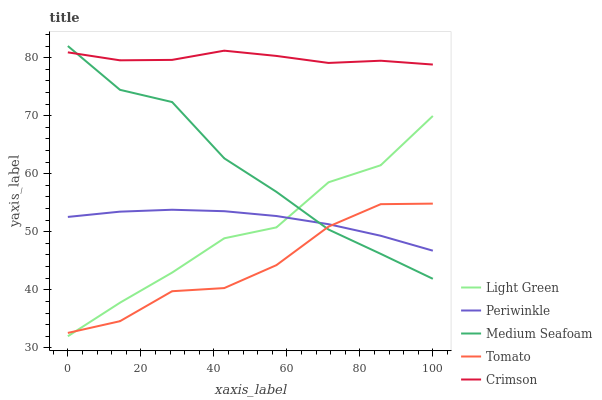Does Tomato have the minimum area under the curve?
Answer yes or no. Yes. Does Crimson have the maximum area under the curve?
Answer yes or no. Yes. Does Periwinkle have the minimum area under the curve?
Answer yes or no. No. Does Periwinkle have the maximum area under the curve?
Answer yes or no. No. Is Periwinkle the smoothest?
Answer yes or no. Yes. Is Light Green the roughest?
Answer yes or no. Yes. Is Crimson the smoothest?
Answer yes or no. No. Is Crimson the roughest?
Answer yes or no. No. Does Light Green have the lowest value?
Answer yes or no. Yes. Does Periwinkle have the lowest value?
Answer yes or no. No. Does Medium Seafoam have the highest value?
Answer yes or no. Yes. Does Crimson have the highest value?
Answer yes or no. No. Is Light Green less than Crimson?
Answer yes or no. Yes. Is Crimson greater than Light Green?
Answer yes or no. Yes. Does Periwinkle intersect Tomato?
Answer yes or no. Yes. Is Periwinkle less than Tomato?
Answer yes or no. No. Is Periwinkle greater than Tomato?
Answer yes or no. No. Does Light Green intersect Crimson?
Answer yes or no. No. 